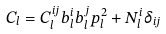Convert formula to latex. <formula><loc_0><loc_0><loc_500><loc_500>C _ { l } = C _ { l } ^ { i j } b _ { l } ^ { i } b _ { l } ^ { j } p _ { l } ^ { 2 } + N _ { l } ^ { i } \delta _ { i j }</formula> 